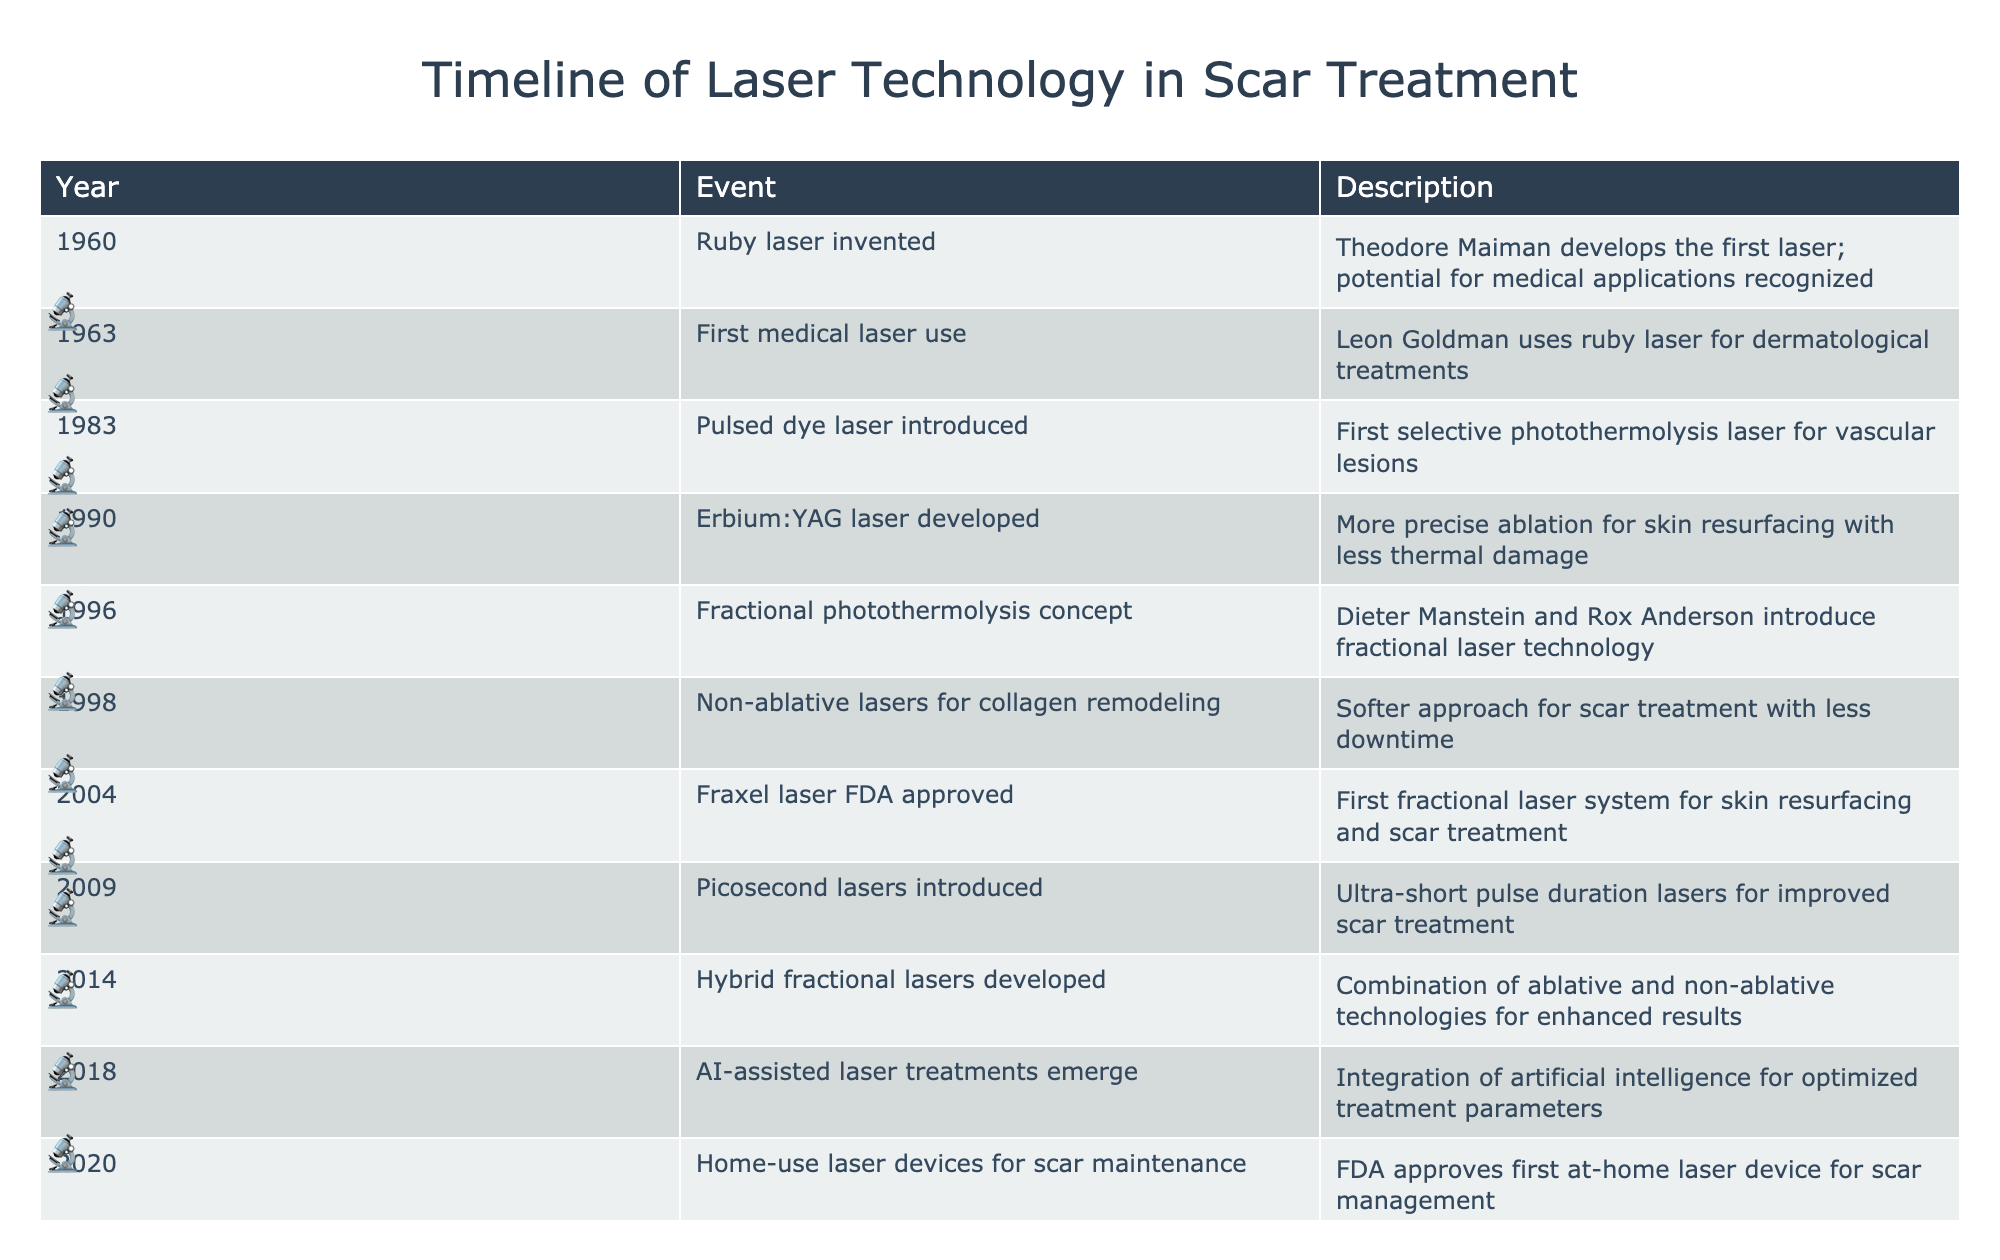What year was the first medical laser used for dermatological treatments? The table lists the events in chronological order. The first medical laser use in dermatology is noted as occurring in 1963.
Answer: 1963 What is the difference in years between the introduction of the pulsed dye laser and the FDA approval of the Fraxel laser? The pulsed dye laser was introduced in 1983, and the Fraxel laser was FDA approved in 2004. The difference in years is 2004 - 1983 = 21 years.
Answer: 21 years Was the Erbium:YAG laser developed before or after the introduction of non-ablative lasers for collagen remodeling? The table indicates that the Erbium:YAG laser was developed in 1990, and non-ablative lasers for collagen remodeling were introduced in 1998. Since 1990 is before 1998, the statement is true.
Answer: Yes Which event in the timeline introduced the concept of fractional laser technology, and what year did it occur? The timeline shows that the fractional photothermolysis concept was introduced in 1996.
Answer: Fractional photothermolysis concept in 1996 How many years passed from the invention of the ruby laser to the introduction of picosecond lasers? The ruby laser was invented in 1960, and picosecond lasers were introduced in 2009. The total years are 2009 - 1960 = 49 years.
Answer: 49 years Was there a significant advancement in laser technology for scar treatment in 2014? Looking at the timeline, 2014 marks the development of hybrid fractional lasers, which combine ablative and non-ablative technologies for improved outcomes. This represents a significant advancement.
Answer: Yes What is the significance of the year 2022 in the context of laser technology for scar treatment? The year 2022 saw the introduction of 3D-printed personalized laser applicators, highlighting an innovative approach to improving treatment outcomes.
Answer: Introduction of 3D-printed personalized laser applicators Which decade saw the most advancements listed in the timeline? Reviewing the table, the period from the 1990s to 2010s has multiple advancements such as the development of the Erbium:YAG laser, fractional photothermolysis, and hybrid fractional lasers. Thus, the 2000s represented a peak decade for advancements.
Answer: 2000s What was the focus of laser technology advancements from 1998 to 2004? The years from 1998 to 2004 saw a shift toward fractional lasers, beginning with non-ablative lasers for collagen remodeling in 1998 and leading to the FDA approval of the Fraxel laser in 2004, aimed at scar treatment through fractional resurfacing.
Answer: Focus on fractional laser technology 